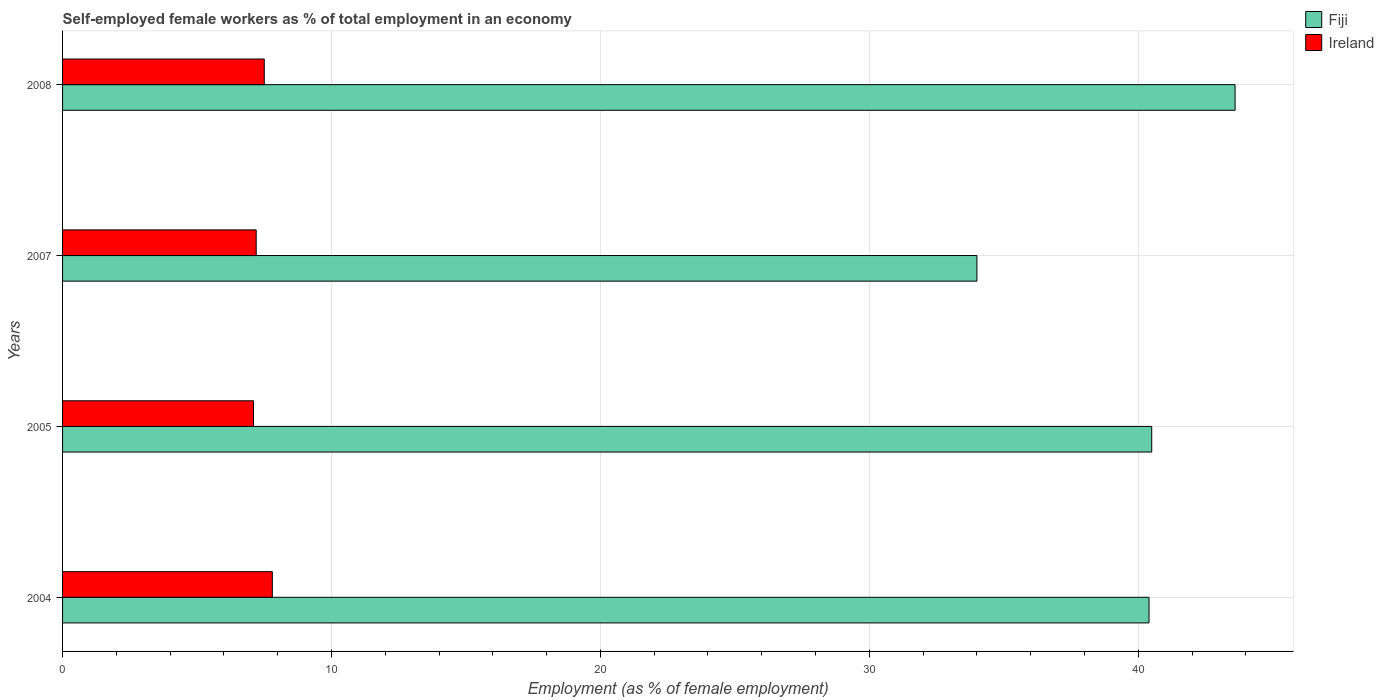How many different coloured bars are there?
Make the answer very short. 2. Are the number of bars per tick equal to the number of legend labels?
Give a very brief answer. Yes. What is the label of the 3rd group of bars from the top?
Offer a terse response. 2005. What is the percentage of self-employed female workers in Fiji in 2004?
Offer a terse response. 40.4. Across all years, what is the maximum percentage of self-employed female workers in Fiji?
Provide a short and direct response. 43.6. Across all years, what is the minimum percentage of self-employed female workers in Fiji?
Offer a very short reply. 34. In which year was the percentage of self-employed female workers in Fiji maximum?
Offer a terse response. 2008. What is the total percentage of self-employed female workers in Ireland in the graph?
Your response must be concise. 29.6. What is the difference between the percentage of self-employed female workers in Ireland in 2005 and that in 2008?
Provide a short and direct response. -0.4. What is the difference between the percentage of self-employed female workers in Ireland in 2005 and the percentage of self-employed female workers in Fiji in 2007?
Give a very brief answer. -26.9. What is the average percentage of self-employed female workers in Ireland per year?
Offer a terse response. 7.4. In the year 2005, what is the difference between the percentage of self-employed female workers in Fiji and percentage of self-employed female workers in Ireland?
Ensure brevity in your answer.  33.4. What is the ratio of the percentage of self-employed female workers in Fiji in 2007 to that in 2008?
Your answer should be compact. 0.78. Is the difference between the percentage of self-employed female workers in Fiji in 2004 and 2008 greater than the difference between the percentage of self-employed female workers in Ireland in 2004 and 2008?
Give a very brief answer. No. What is the difference between the highest and the second highest percentage of self-employed female workers in Fiji?
Provide a succinct answer. 3.1. What is the difference between the highest and the lowest percentage of self-employed female workers in Ireland?
Offer a terse response. 0.7. In how many years, is the percentage of self-employed female workers in Fiji greater than the average percentage of self-employed female workers in Fiji taken over all years?
Your answer should be compact. 3. What does the 2nd bar from the top in 2004 represents?
Your answer should be compact. Fiji. What does the 1st bar from the bottom in 2005 represents?
Provide a short and direct response. Fiji. Are all the bars in the graph horizontal?
Provide a succinct answer. Yes. Are the values on the major ticks of X-axis written in scientific E-notation?
Provide a short and direct response. No. Does the graph contain any zero values?
Your answer should be very brief. No. Where does the legend appear in the graph?
Your answer should be compact. Top right. How are the legend labels stacked?
Provide a short and direct response. Vertical. What is the title of the graph?
Your answer should be compact. Self-employed female workers as % of total employment in an economy. Does "Bangladesh" appear as one of the legend labels in the graph?
Ensure brevity in your answer.  No. What is the label or title of the X-axis?
Ensure brevity in your answer.  Employment (as % of female employment). What is the Employment (as % of female employment) of Fiji in 2004?
Your answer should be compact. 40.4. What is the Employment (as % of female employment) of Ireland in 2004?
Keep it short and to the point. 7.8. What is the Employment (as % of female employment) of Fiji in 2005?
Give a very brief answer. 40.5. What is the Employment (as % of female employment) of Ireland in 2005?
Make the answer very short. 7.1. What is the Employment (as % of female employment) in Fiji in 2007?
Offer a very short reply. 34. What is the Employment (as % of female employment) in Ireland in 2007?
Your answer should be compact. 7.2. What is the Employment (as % of female employment) in Fiji in 2008?
Your response must be concise. 43.6. What is the Employment (as % of female employment) in Ireland in 2008?
Keep it short and to the point. 7.5. Across all years, what is the maximum Employment (as % of female employment) in Fiji?
Your response must be concise. 43.6. Across all years, what is the maximum Employment (as % of female employment) in Ireland?
Your answer should be very brief. 7.8. Across all years, what is the minimum Employment (as % of female employment) in Fiji?
Give a very brief answer. 34. Across all years, what is the minimum Employment (as % of female employment) of Ireland?
Provide a short and direct response. 7.1. What is the total Employment (as % of female employment) in Fiji in the graph?
Your answer should be very brief. 158.5. What is the total Employment (as % of female employment) in Ireland in the graph?
Keep it short and to the point. 29.6. What is the difference between the Employment (as % of female employment) of Fiji in 2004 and that in 2005?
Your response must be concise. -0.1. What is the difference between the Employment (as % of female employment) in Fiji in 2004 and that in 2007?
Offer a very short reply. 6.4. What is the difference between the Employment (as % of female employment) in Ireland in 2004 and that in 2007?
Offer a terse response. 0.6. What is the difference between the Employment (as % of female employment) in Fiji in 2005 and that in 2007?
Your answer should be very brief. 6.5. What is the difference between the Employment (as % of female employment) in Fiji in 2005 and that in 2008?
Your response must be concise. -3.1. What is the difference between the Employment (as % of female employment) in Fiji in 2007 and that in 2008?
Your answer should be compact. -9.6. What is the difference between the Employment (as % of female employment) of Ireland in 2007 and that in 2008?
Provide a short and direct response. -0.3. What is the difference between the Employment (as % of female employment) in Fiji in 2004 and the Employment (as % of female employment) in Ireland in 2005?
Give a very brief answer. 33.3. What is the difference between the Employment (as % of female employment) in Fiji in 2004 and the Employment (as % of female employment) in Ireland in 2007?
Offer a terse response. 33.2. What is the difference between the Employment (as % of female employment) of Fiji in 2004 and the Employment (as % of female employment) of Ireland in 2008?
Your answer should be very brief. 32.9. What is the difference between the Employment (as % of female employment) of Fiji in 2005 and the Employment (as % of female employment) of Ireland in 2007?
Provide a short and direct response. 33.3. What is the difference between the Employment (as % of female employment) in Fiji in 2005 and the Employment (as % of female employment) in Ireland in 2008?
Make the answer very short. 33. What is the average Employment (as % of female employment) of Fiji per year?
Provide a succinct answer. 39.62. In the year 2004, what is the difference between the Employment (as % of female employment) of Fiji and Employment (as % of female employment) of Ireland?
Make the answer very short. 32.6. In the year 2005, what is the difference between the Employment (as % of female employment) in Fiji and Employment (as % of female employment) in Ireland?
Ensure brevity in your answer.  33.4. In the year 2007, what is the difference between the Employment (as % of female employment) in Fiji and Employment (as % of female employment) in Ireland?
Offer a very short reply. 26.8. In the year 2008, what is the difference between the Employment (as % of female employment) in Fiji and Employment (as % of female employment) in Ireland?
Make the answer very short. 36.1. What is the ratio of the Employment (as % of female employment) in Ireland in 2004 to that in 2005?
Give a very brief answer. 1.1. What is the ratio of the Employment (as % of female employment) of Fiji in 2004 to that in 2007?
Give a very brief answer. 1.19. What is the ratio of the Employment (as % of female employment) of Fiji in 2004 to that in 2008?
Keep it short and to the point. 0.93. What is the ratio of the Employment (as % of female employment) of Fiji in 2005 to that in 2007?
Provide a short and direct response. 1.19. What is the ratio of the Employment (as % of female employment) of Ireland in 2005 to that in 2007?
Your answer should be compact. 0.99. What is the ratio of the Employment (as % of female employment) of Fiji in 2005 to that in 2008?
Your answer should be very brief. 0.93. What is the ratio of the Employment (as % of female employment) in Ireland in 2005 to that in 2008?
Your answer should be very brief. 0.95. What is the ratio of the Employment (as % of female employment) in Fiji in 2007 to that in 2008?
Your response must be concise. 0.78. 